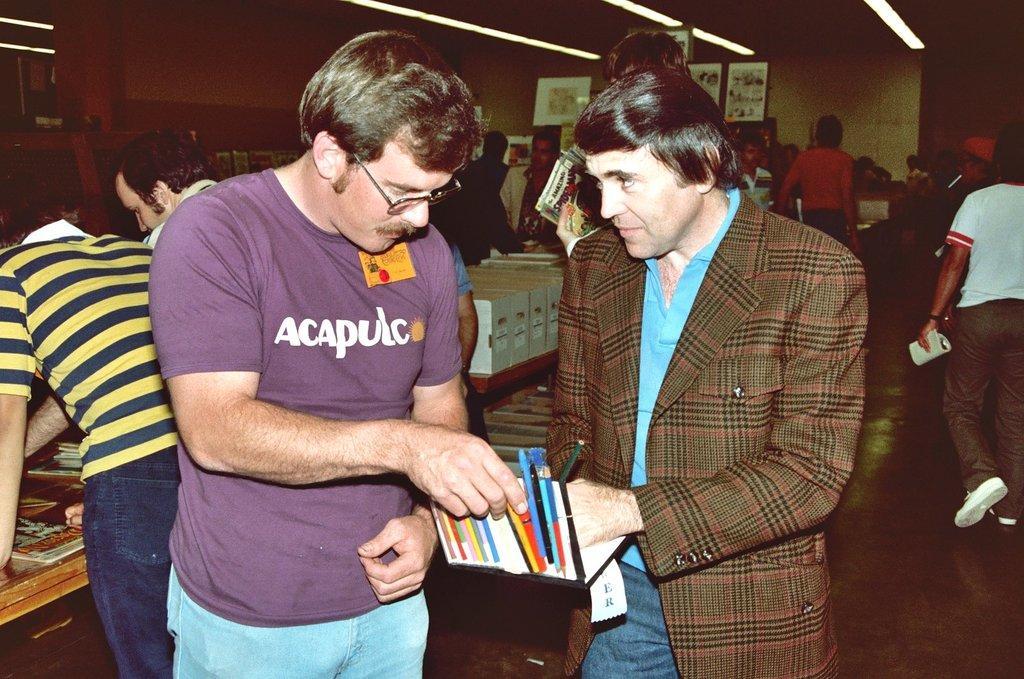Please provide a concise description of this image. In the image to the left side there is a man with yellow and blue lines t-shirt and blue jeans is standing. Behind him there is a man with purple t-shirt and blue pant is standing and holding the pens packet in his hand. Beside him there is a man with brown jacket, blue t-shirt is standing. Behind them there are few people and also there are few cupboards with few items in it. And in the background there is a wall with frames. And to the top of the image there are lights. 